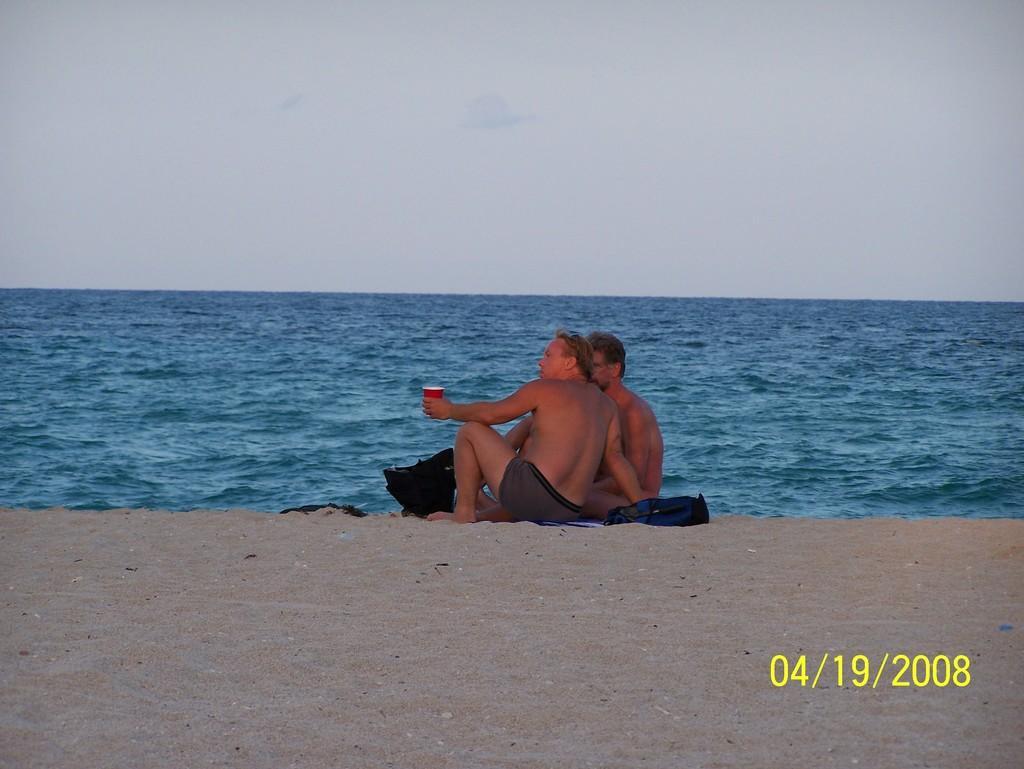Please provide a concise description of this image. In this image I can see the sand and two persons are sitting on the sand. I can see one of them is holding a red colored cup in his hand. I can see few black colored objects and in the background I can see the water and the sky. 